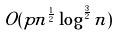<formula> <loc_0><loc_0><loc_500><loc_500>O ( p n ^ { \frac { 1 } { 2 } } \log ^ { \frac { 3 } { 2 } } n )</formula> 